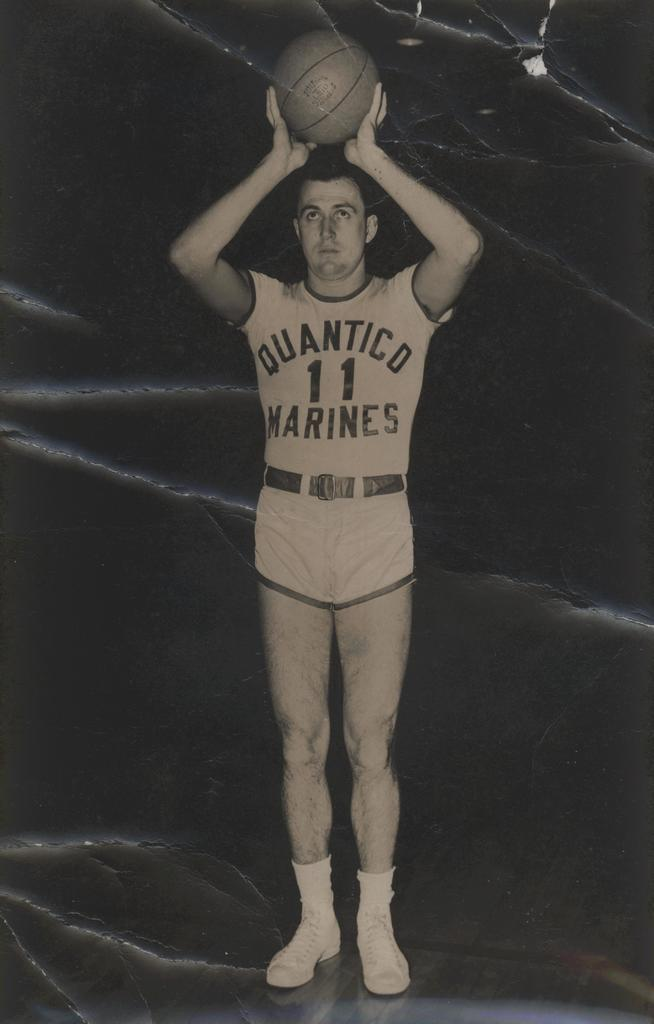Provide a one-sentence caption for the provided image. a man playing basketball while wearing a quantico marines jersey number 11. 